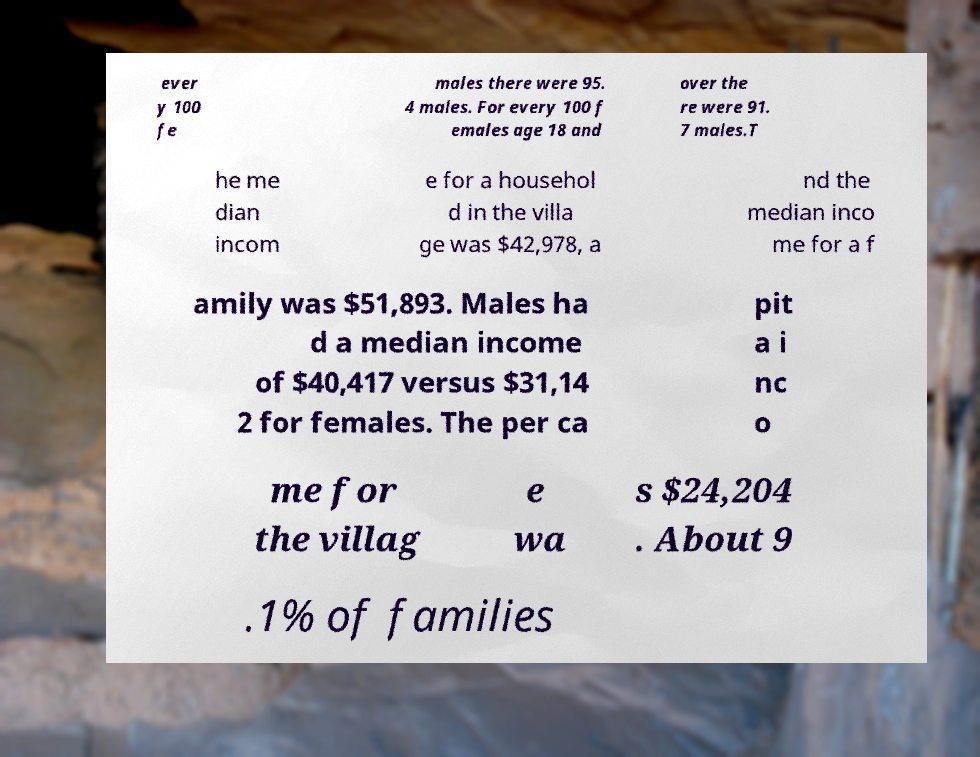Could you extract and type out the text from this image? ever y 100 fe males there were 95. 4 males. For every 100 f emales age 18 and over the re were 91. 7 males.T he me dian incom e for a househol d in the villa ge was $42,978, a nd the median inco me for a f amily was $51,893. Males ha d a median income of $40,417 versus $31,14 2 for females. The per ca pit a i nc o me for the villag e wa s $24,204 . About 9 .1% of families 